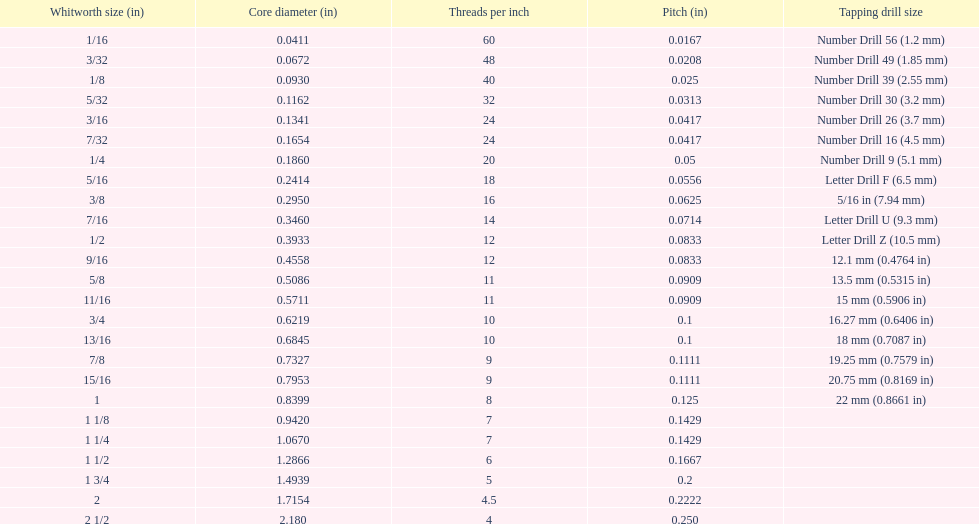Does any whitworth size have the same core diameter as the number drill 26? 3/16. 